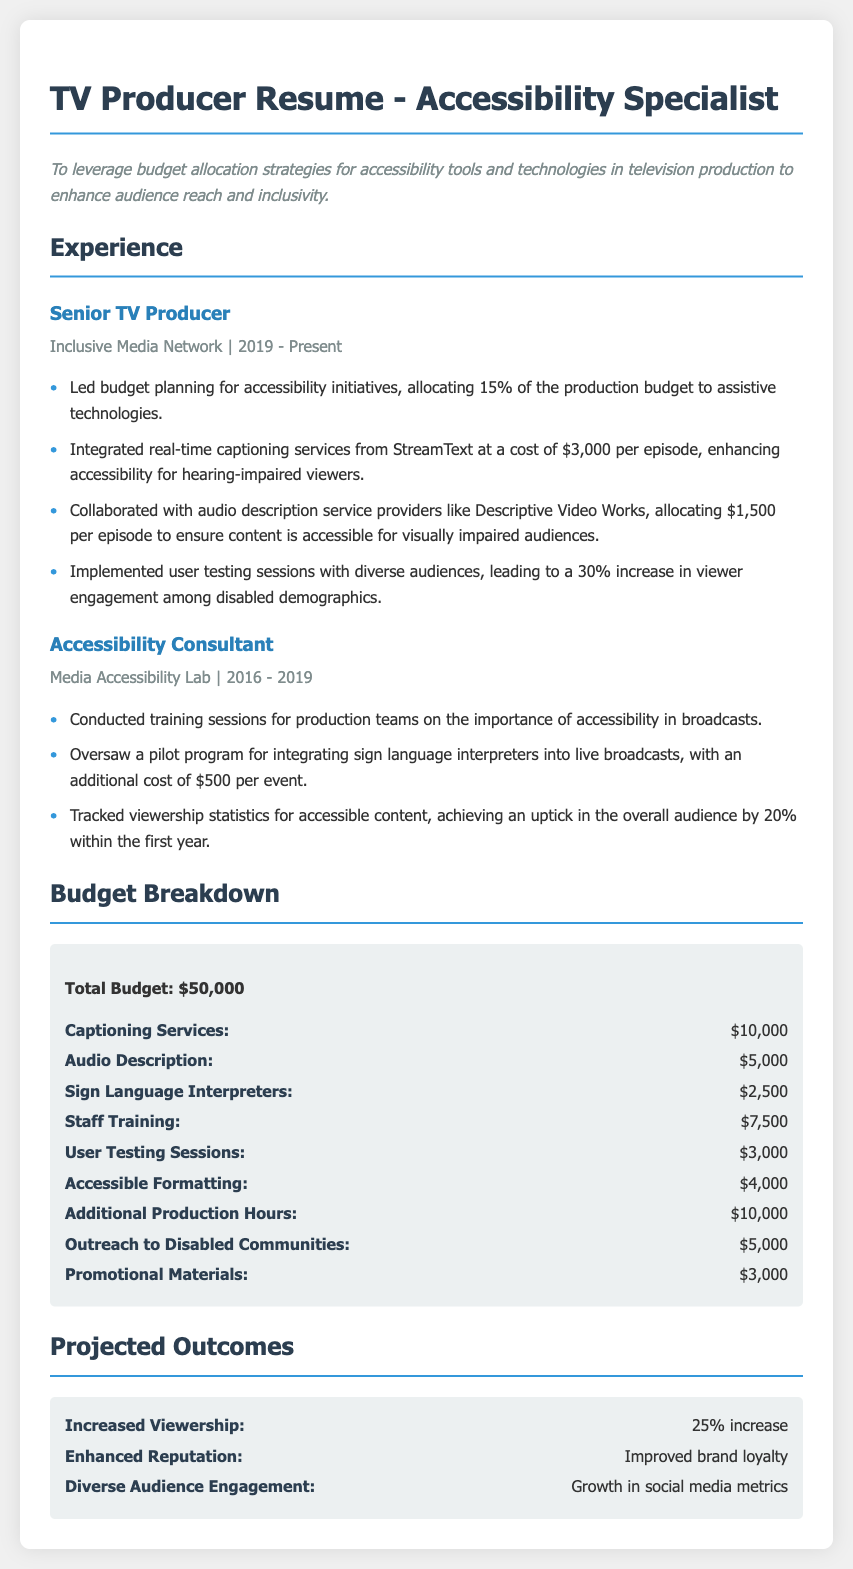What is the total budget allocated for accessibility tools? The total budget is listed at the beginning of the budget breakdown section.
Answer: $50,000 How much is allocated for captioning services? The specific amount for captioning services can be found in the budget breakdown section.
Answer: $10,000 What percentage of the production budget is allocated to assistive technologies? This percentage is mentioned in the experience section under the Senior TV Producer role.
Answer: 15% What is the cost for audio description services per episode? The cost for audio description services is stated in the experience section.
Answer: $1,500 What outcome is associated with the implemented user testing sessions? The specific outcome resulting from user testing sessions can be found in the experience section.
Answer: 30% increase How much is the budget set aside for outreach to disabled communities? This amount can be found in the budget breakdown section specifically under outreach.
Answer: $5,000 What was the increase in overall audience due to accessible content? The increase in audience statistics is provided in the experience section under Accessibility Consultant role.
Answer: 20% What service is provided at a cost of $3,000 per episode? The service mentioned refers to a specific accessibility feature indicated in the experience section.
Answer: Real-time captioning services What training is conducted for production teams? The nature of the training is described in the experience section under Accessibility Consultant.
Answer: Training sessions on accessibility What is the projected increase in viewership from the initiatives? This figure can be found in the projected outcomes section of the document.
Answer: 25% increase 